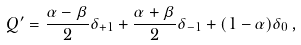<formula> <loc_0><loc_0><loc_500><loc_500>Q ^ { \prime } = \frac { \alpha - \beta } { 2 } \delta _ { + 1 } + \frac { \alpha + \beta } { 2 } \delta _ { - 1 } + ( 1 - \alpha ) \delta _ { 0 } \, ,</formula> 